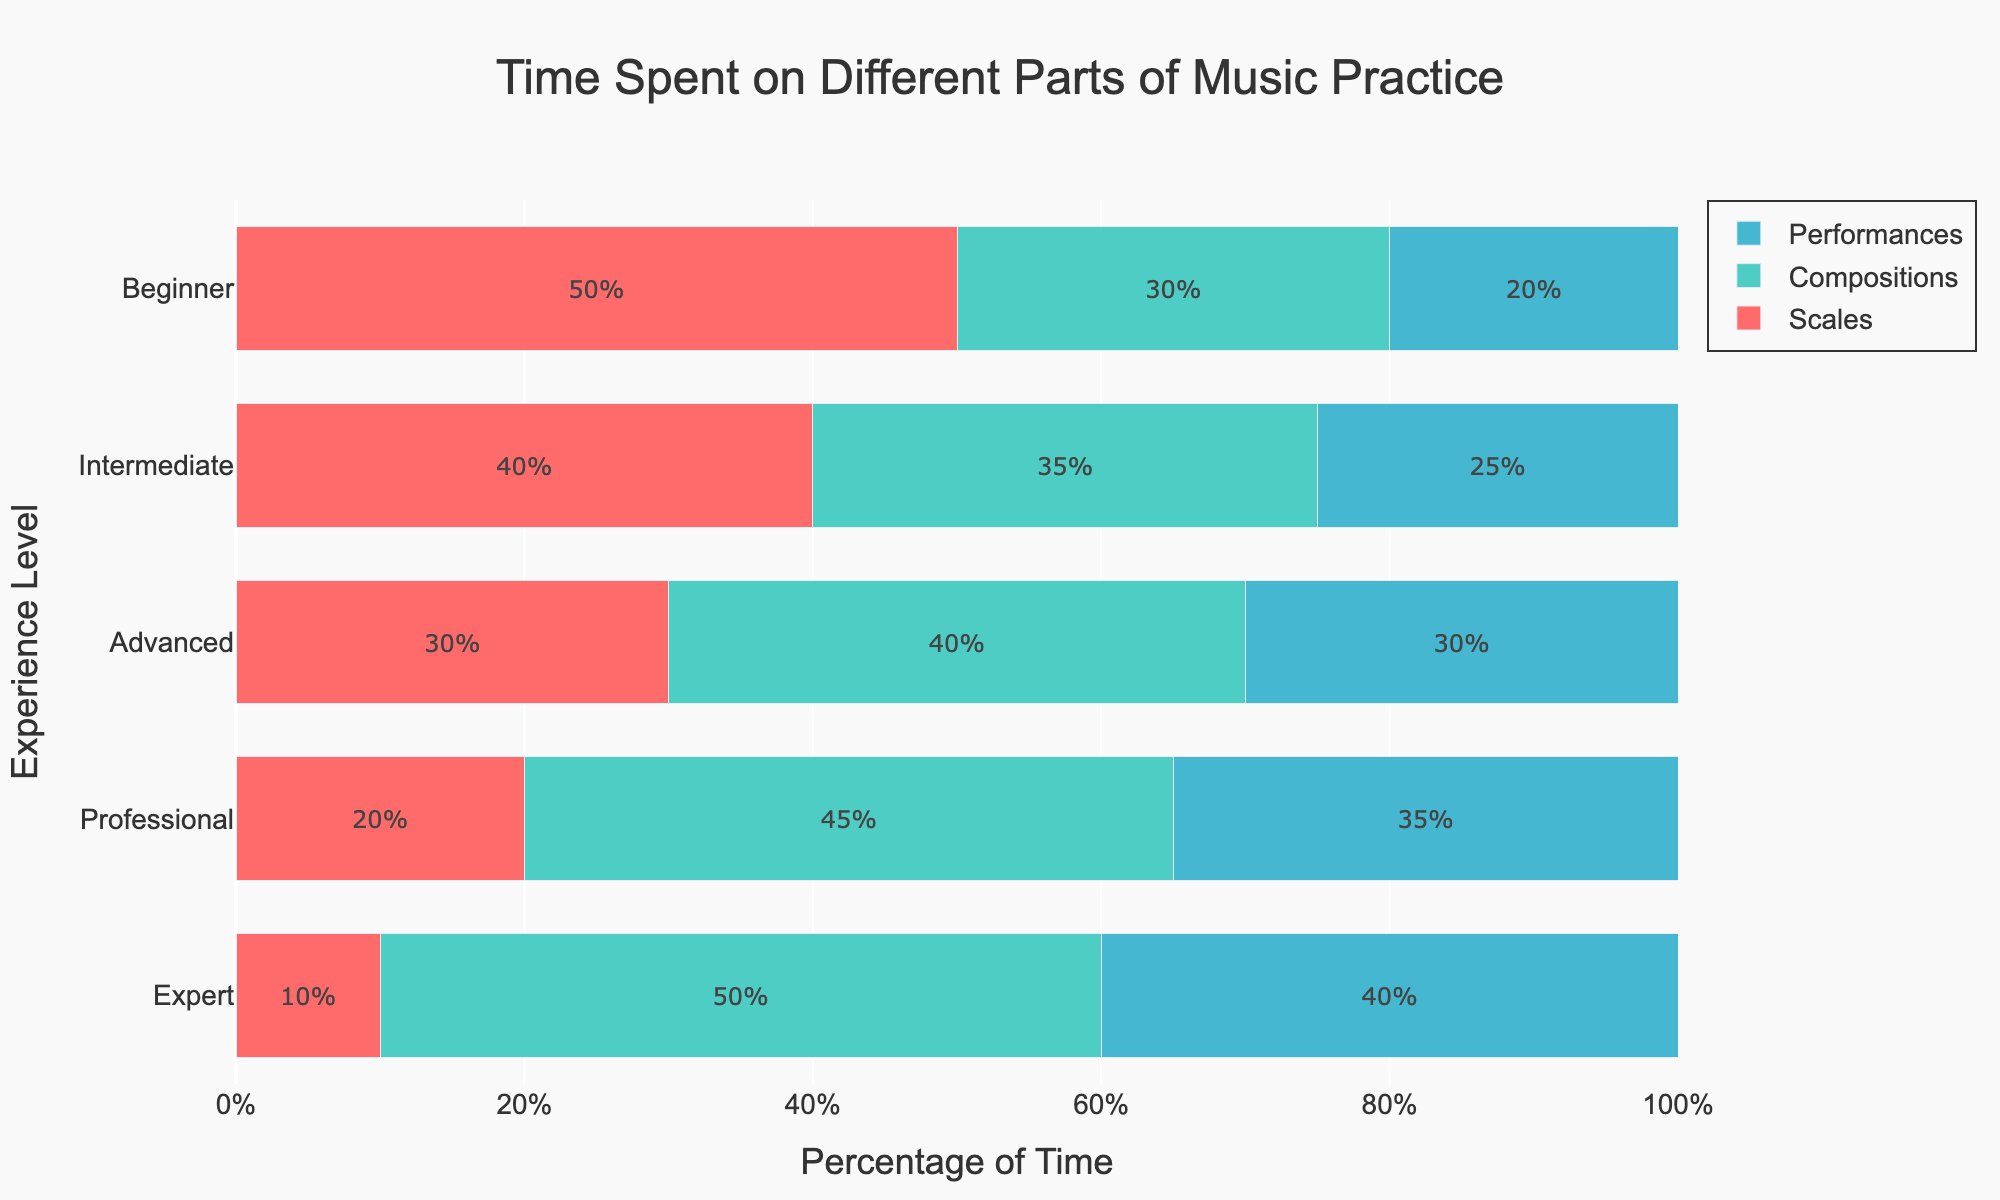What experience level spends the most time on scales? By looking at the plot, we can see that the red bars represent the time spent on scales. The longest red bar is for the "Beginner" level.
Answer: Beginner Which group spends an equal amount of time on compositions and scales? We can observe the lengths of the red and green bars for each experience level. The "Beginner" and "Intermediate" levels do not show equal lengths for compositions and scales. For the "Advanced" level, compositions (40%) and scales (30%) are not equal. The "Professional" and "Expert" levels also do not have equal lengths for compositions and scales. Therefore, no group spends an equal amount of time on compositions and scales.
Answer: None What is the total percentage of time spent on music practice by Intermediate musicians? We add the percentages for scales, compositions, and performances for the Intermediate level: 40 + 35 + 25 = 100%.
Answer: 100% Which experience level shows the smallest percentage for scales? By comparing the lengths of the red bars, we see that the "Expert" level has the shortest red bar, representing 10%.
Answer: Expert How much more do Experts spend on compositions than Beginners? The percentage for compositions for Experts is 50%, and for Beginners, it is 30%. The difference is 50% - 30% = 20%.
Answer: 20% Which experience level shows the highest percentage for performances? By comparing the blue bars, we see that the "Expert" level has the longest blue bar, representing 40%.
Answer: Expert How does the percentage of time spent on performances differ between Intermediate and Professional musicians? The percentage for performances for Intermediate musicians is 25%, and for Professional musicians, it is 35%. The difference is 35% - 25% = 10%.
Answer: 10% Does any group spend more than half their time on a single activity? Both "Professional" (45%) and "Expert" (50%) levels spend the highest amount of time on compositions, and these are under 50%. Therefore, no group spends more than half their time on a single activity.
Answer: No What is the sum of the time spent on scales and performances by Advanced musicians? For the Advanced level, the percentages for scales and performances are 30% and 30%, respectively. Adding them gives 30 + 30 = 60%.
Answer: 60% Which experience level has the most balanced distribution of time among scales, compositions, and performances? The "Advanced" level seems to have the most balanced distribution, with 30% on scales, 40% on compositions, and 30% on performances. Other levels have more uneven distributions.
Answer: Advanced 